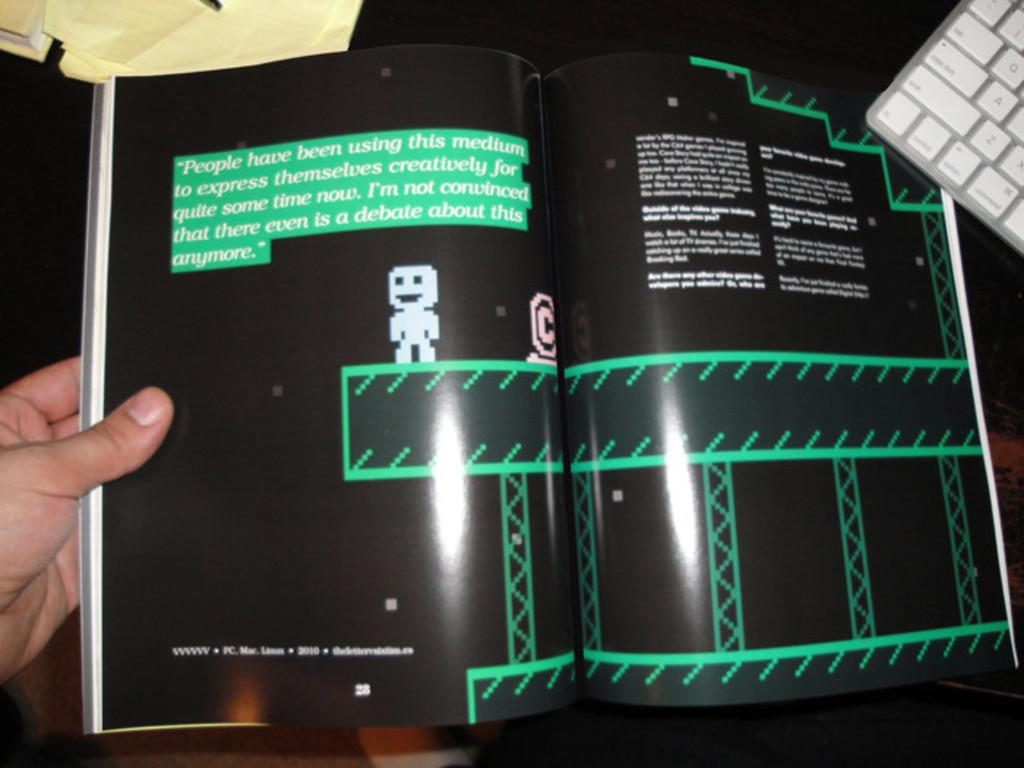Provide a one-sentence caption for the provided image. "People have been using this medium to express themselves creatively for quite some time now" is printed on the top of this book page. 